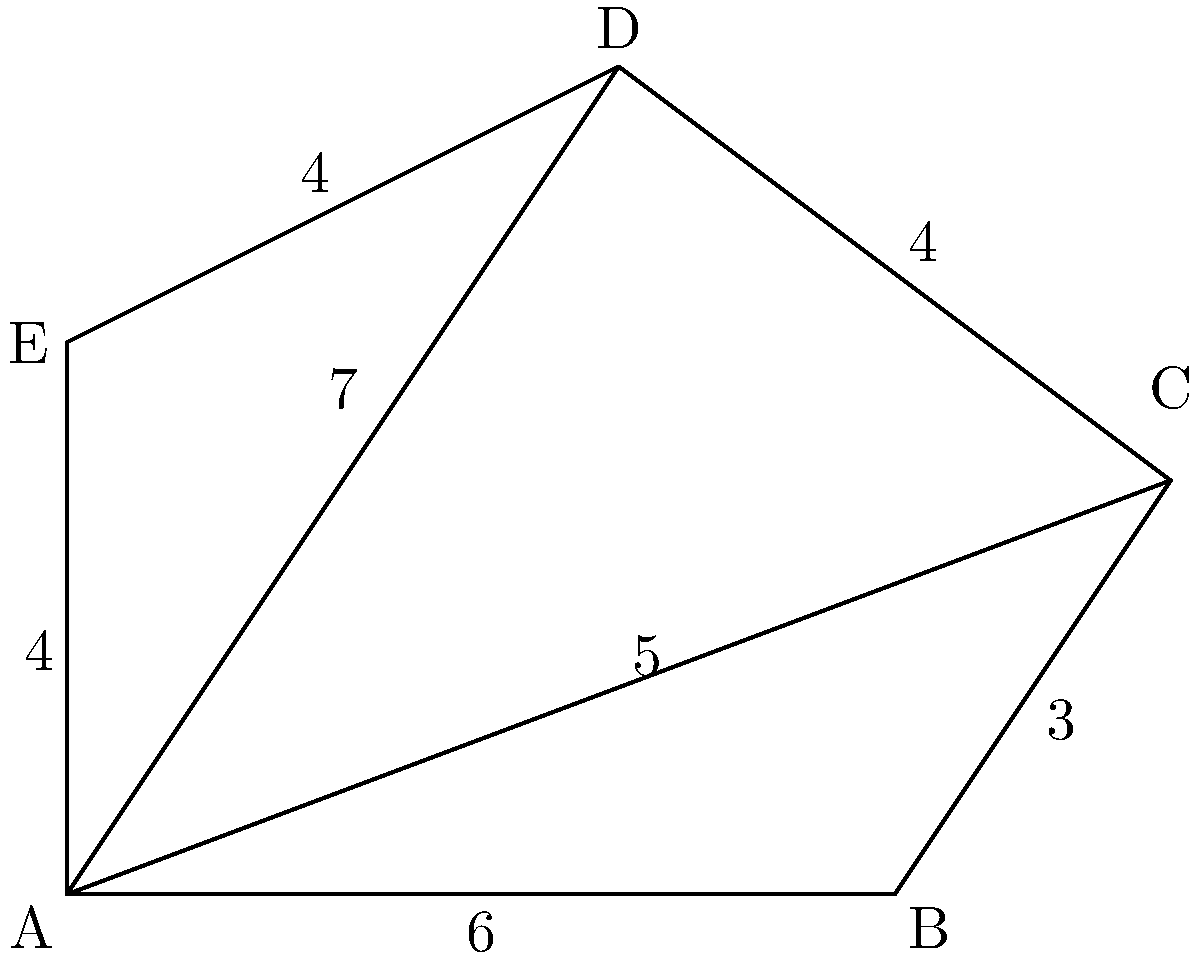A new military base is being planned with a pentagon-shaped layout. The dimensions of the sides are shown in the diagram, along with two diagonals. What is the total area of this pentagon-shaped base in square units? To find the area of the pentagon, we can divide it into three triangles and calculate their areas separately. Let's follow these steps:

1. Triangle ABC:
   Base = 6, Height = 3
   Area = $\frac{1}{2} \times 6 \times 3 = 9$ square units

2. Triangle ACD:
   We can use Heron's formula for this triangle.
   Semi-perimeter $s = \frac{5 + 4 + 7}{2} = 8$
   Area = $\sqrt{s(s-a)(s-b)(s-c)}$
        = $\sqrt{8(8-5)(8-4)(8-7)}$
        = $\sqrt{8 \times 3 \times 4 \times 1}$
        = $\sqrt{96} = 4\sqrt{6}$ square units

3. Triangle ADE:
   Base = 4, Height = 4
   Area = $\frac{1}{2} \times 4 \times 4 = 8$ square units

4. Total Area:
   $9 + 4\sqrt{6} + 8 = 17 + 4\sqrt{6}$ square units

Therefore, the total area of the pentagon-shaped military base is $17 + 4\sqrt{6}$ square units.
Answer: $17 + 4\sqrt{6}$ square units 